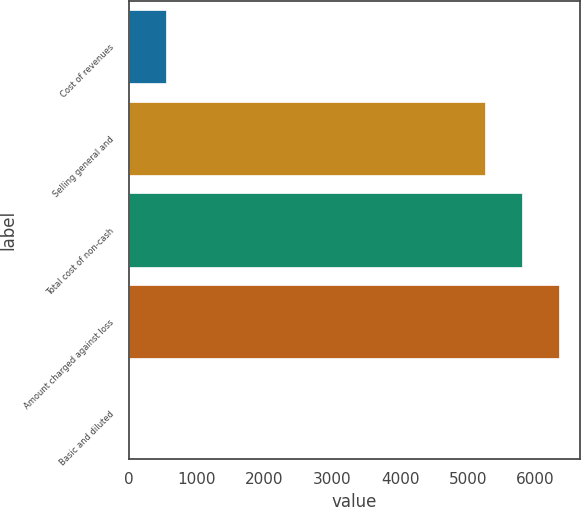<chart> <loc_0><loc_0><loc_500><loc_500><bar_chart><fcel>Cost of revenues<fcel>Selling general and<fcel>Total cost of non-cash<fcel>Amount charged against loss<fcel>Basic and diluted<nl><fcel>541.05<fcel>5259<fcel>5799.99<fcel>6340.98<fcel>0.06<nl></chart> 